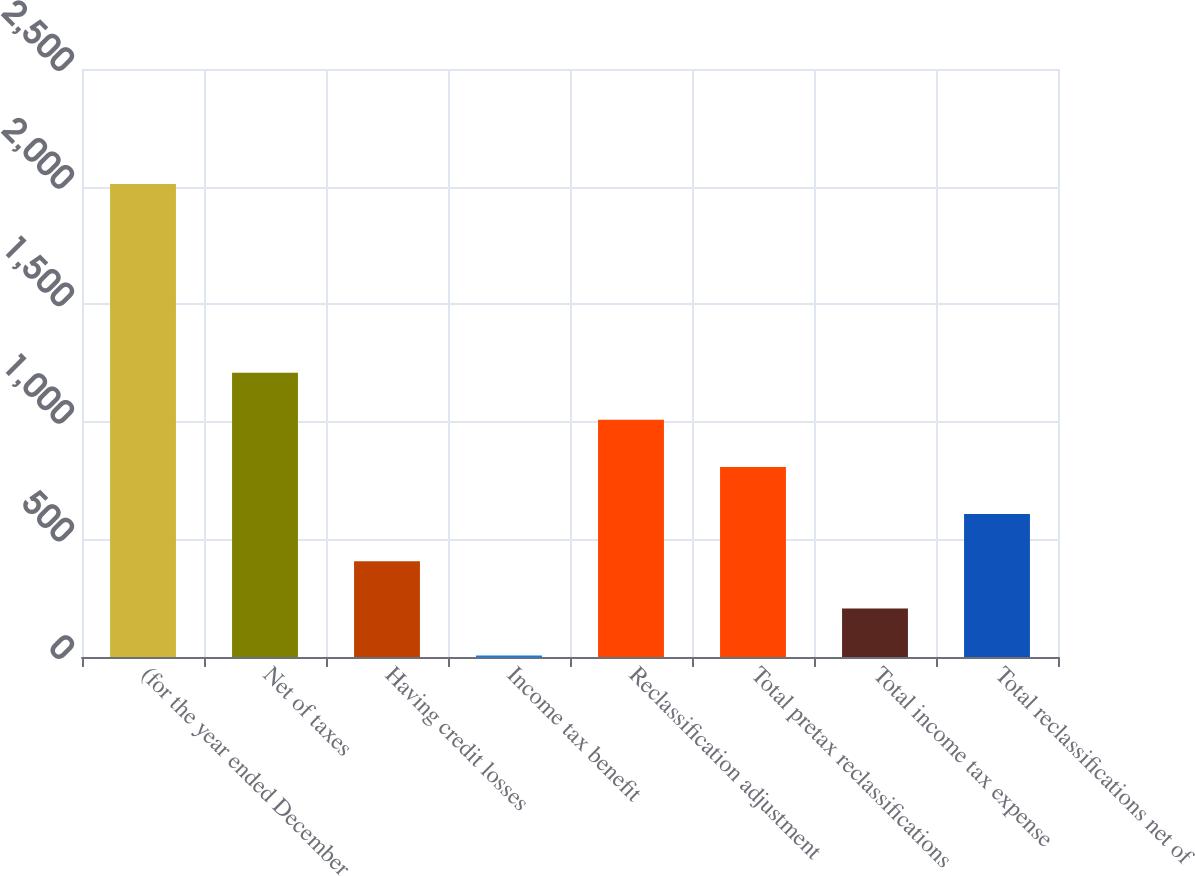<chart> <loc_0><loc_0><loc_500><loc_500><bar_chart><fcel>(for the year ended December<fcel>Net of taxes<fcel>Having credit losses<fcel>Income tax benefit<fcel>Reclassification adjustment<fcel>Total pretax reclassifications<fcel>Total income tax expense<fcel>Total reclassifications net of<nl><fcel>2011<fcel>1209<fcel>407<fcel>6<fcel>1008.5<fcel>808<fcel>206.5<fcel>607.5<nl></chart> 